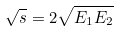Convert formula to latex. <formula><loc_0><loc_0><loc_500><loc_500>\sqrt { s } = 2 \sqrt { E _ { 1 } E _ { 2 } }</formula> 